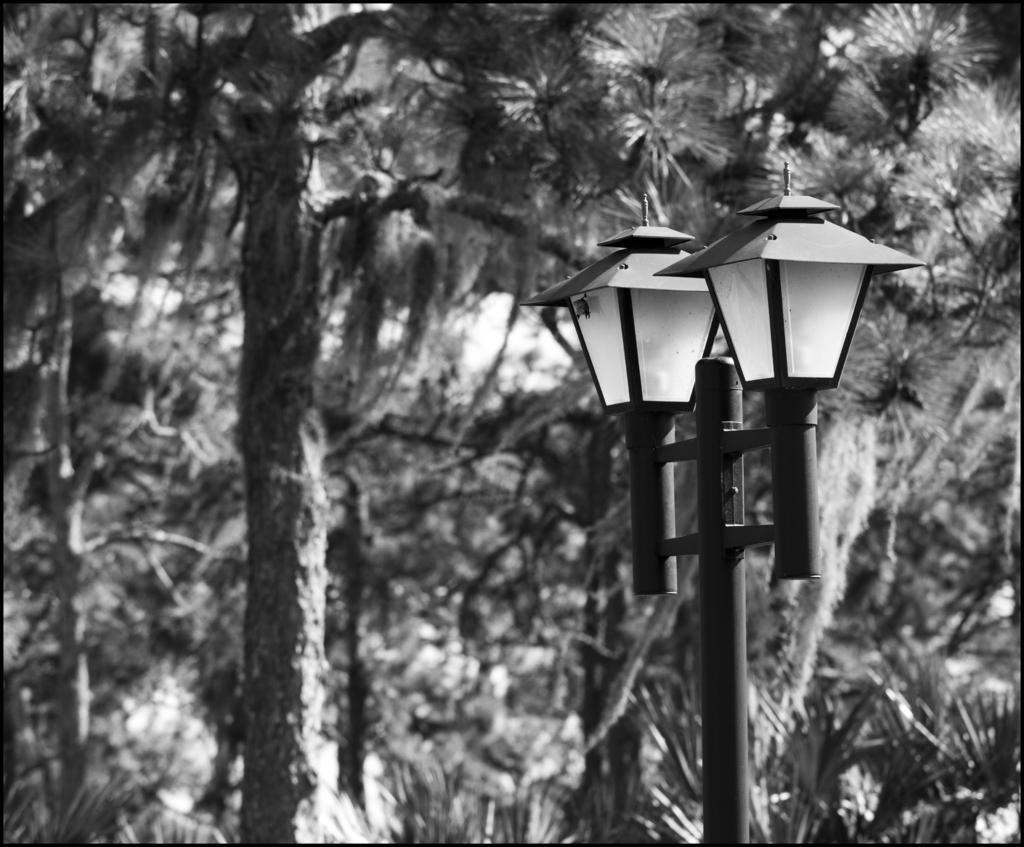What is the main object in the image? There is a pole in the image. What can be seen in the front of the image? There are two lights in the front of the image. What type of natural scenery is visible in the background? There are trees in the background of the image. Can you see any faces engaged in a battle or fight in the image? There are no faces or any indication of a battle or fight present in the image. 